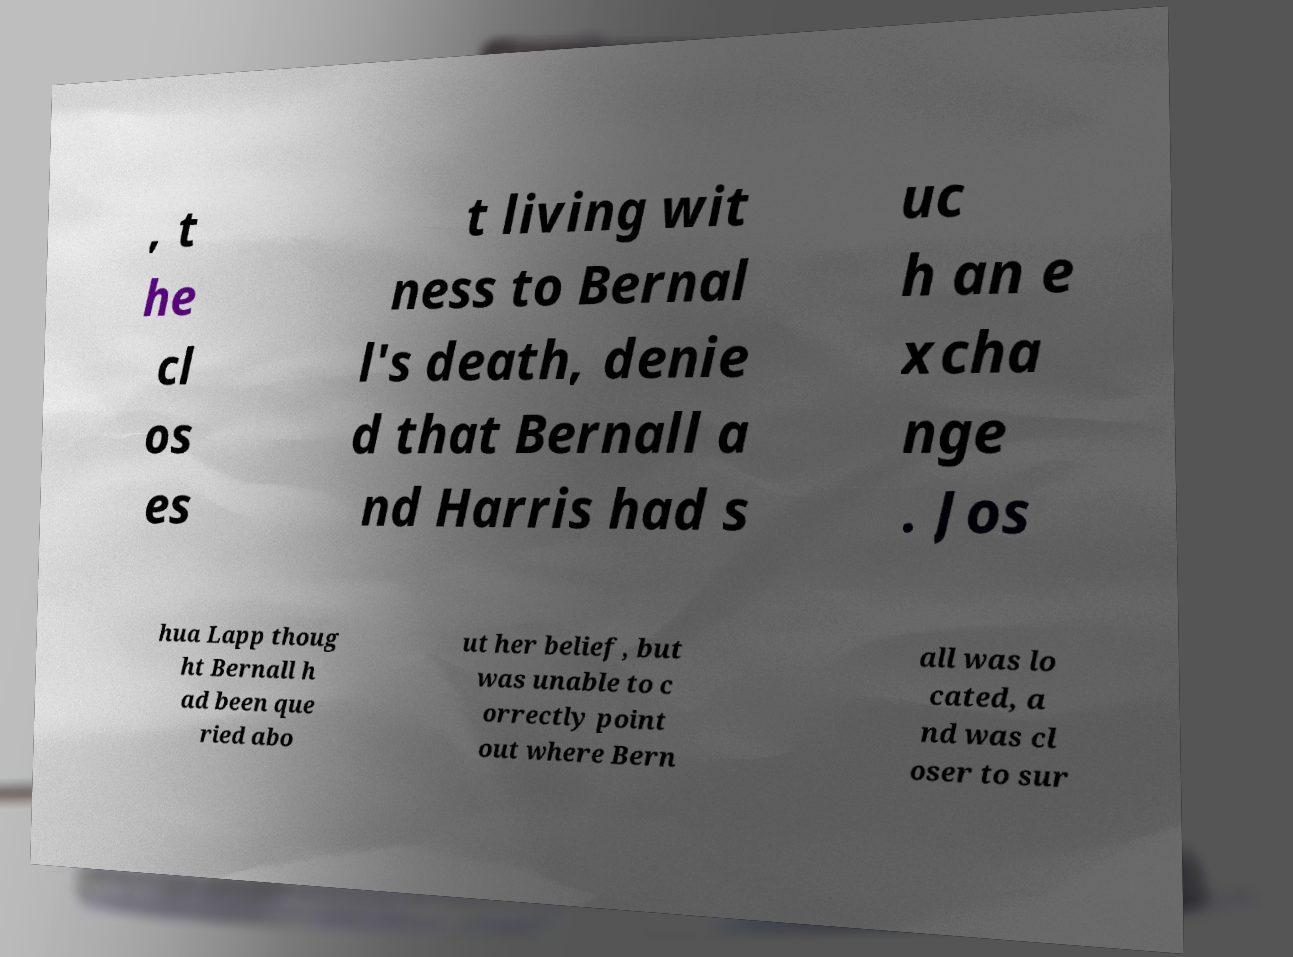Please read and relay the text visible in this image. What does it say? , t he cl os es t living wit ness to Bernal l's death, denie d that Bernall a nd Harris had s uc h an e xcha nge . Jos hua Lapp thoug ht Bernall h ad been que ried abo ut her belief, but was unable to c orrectly point out where Bern all was lo cated, a nd was cl oser to sur 